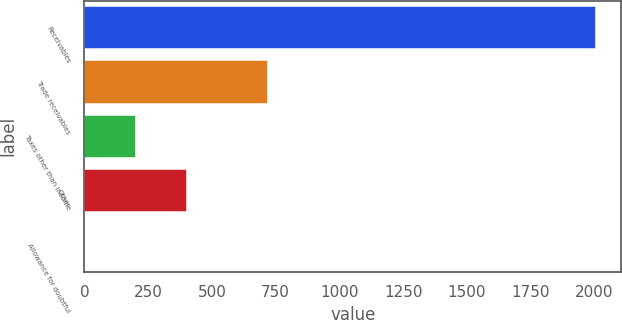<chart> <loc_0><loc_0><loc_500><loc_500><bar_chart><fcel>Receivables<fcel>Trade receivables<fcel>Taxes other than income<fcel>Other<fcel>Allowance for doubtful<nl><fcel>2005<fcel>720<fcel>202.3<fcel>402.6<fcel>2<nl></chart> 